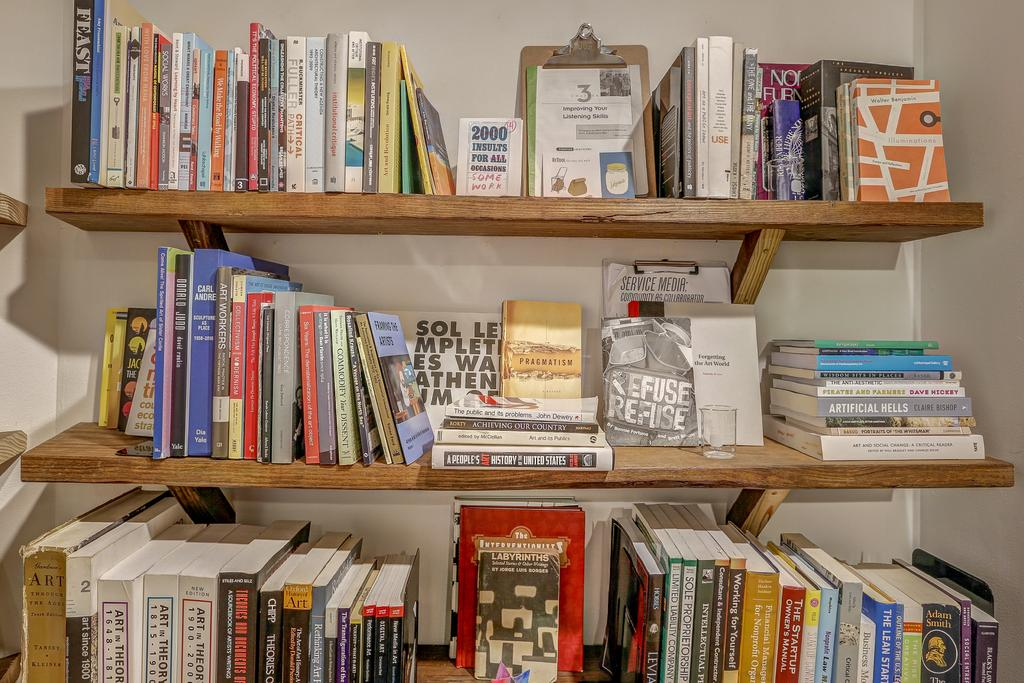Provide a one-sentence caption for the provided image. Three shelves filled with books and one titled "2000 insults for all occasions" on the top shelf. 